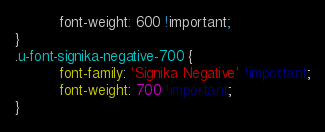Convert code to text. <code><loc_0><loc_0><loc_500><loc_500><_CSS_>          font-weight: 600 !important;
}
.u-font-signika-negative-700 {
          font-family: 'Signika Negative' !important;
          font-weight: 700 !important;
}</code> 